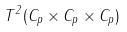Convert formula to latex. <formula><loc_0><loc_0><loc_500><loc_500>T ^ { 2 } ( C _ { p } \times C _ { p } \times C _ { p } )</formula> 